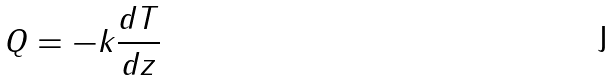<formula> <loc_0><loc_0><loc_500><loc_500>Q = - k \frac { d T } { d z }</formula> 